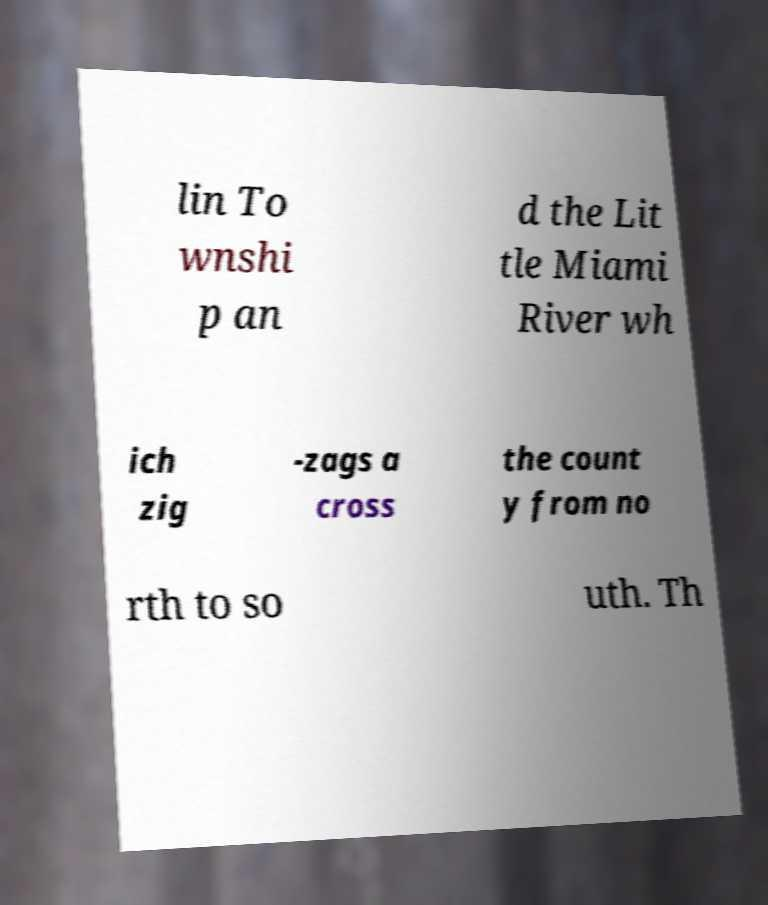Please read and relay the text visible in this image. What does it say? lin To wnshi p an d the Lit tle Miami River wh ich zig -zags a cross the count y from no rth to so uth. Th 